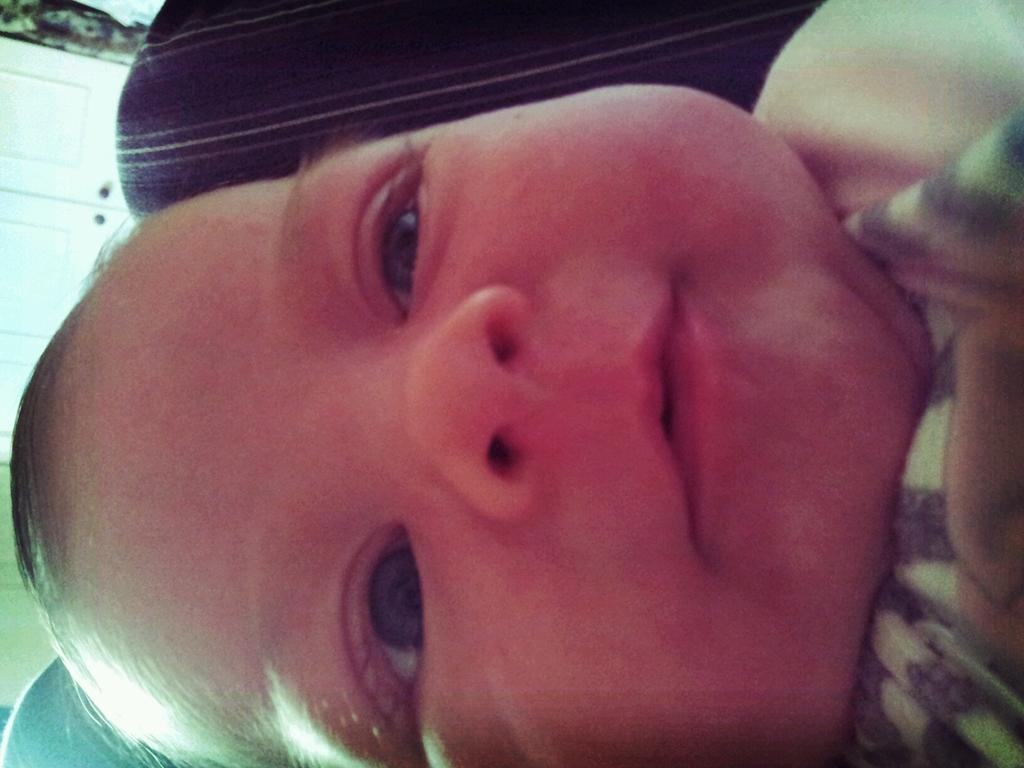What is the main subject of the image? There is a baby in the image. What is the baby doing in the image? The baby is smiling. What can be seen on the left side of the image? There are doors on the left side of the image. What is the color of the doors? The doors are white in color. What type of surprise can be seen on the floor in the image? There is no surprise visible on the floor in the image. 